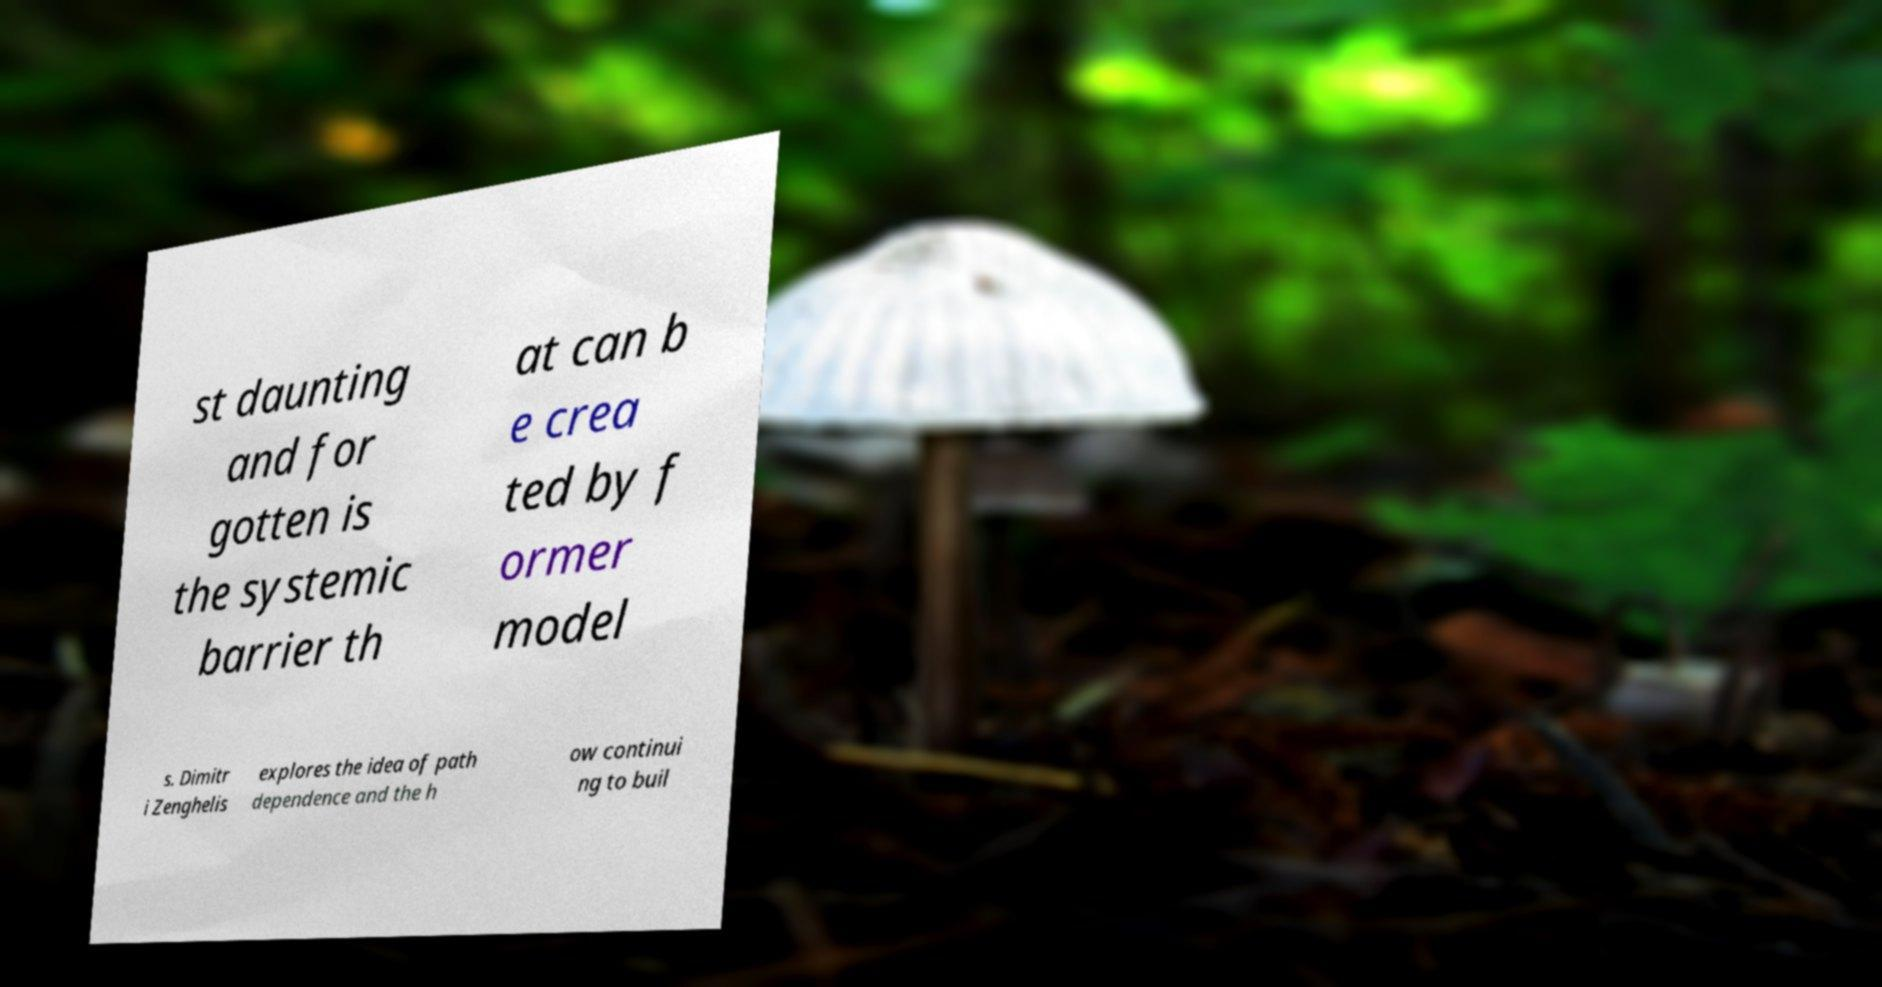Please identify and transcribe the text found in this image. st daunting and for gotten is the systemic barrier th at can b e crea ted by f ormer model s. Dimitr i Zenghelis explores the idea of path dependence and the h ow continui ng to buil 